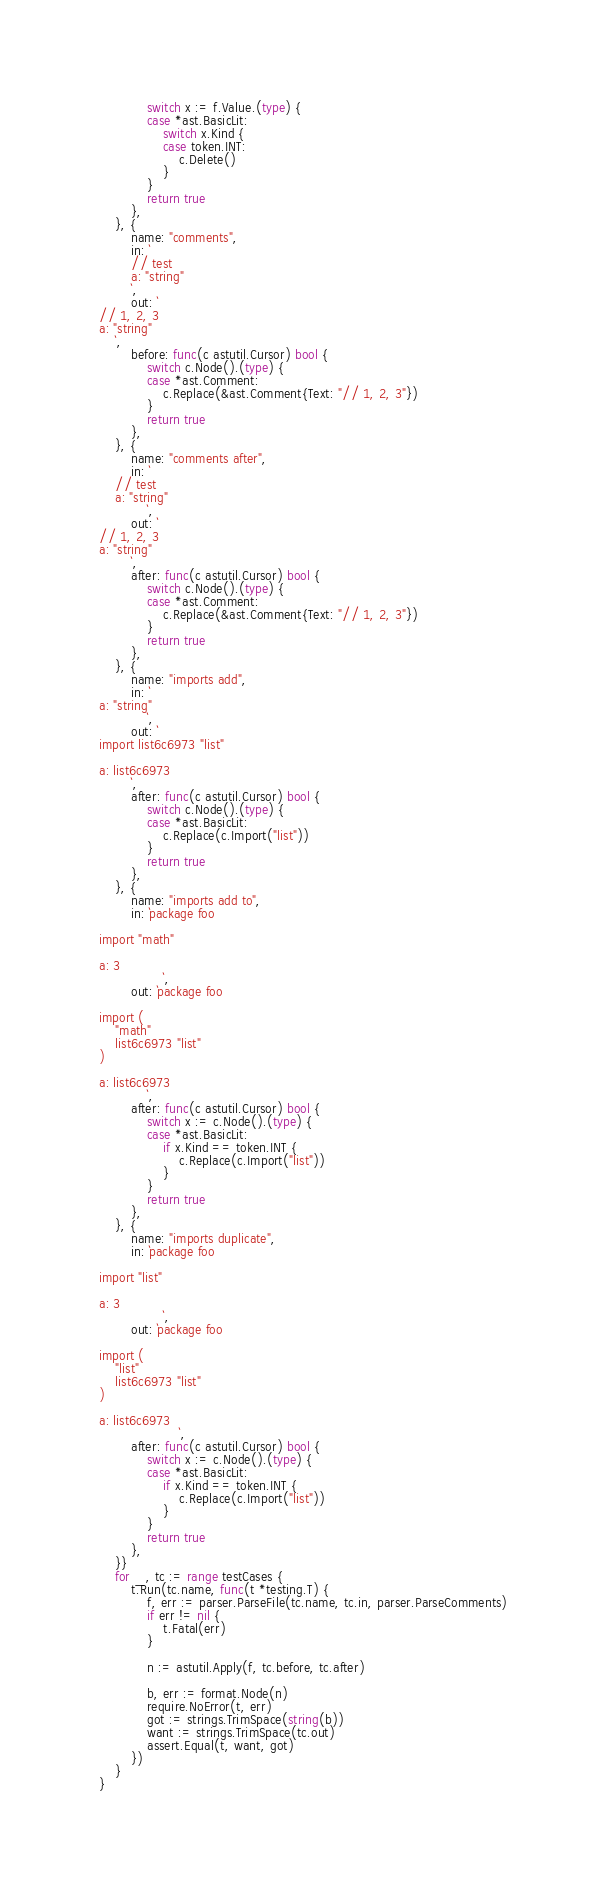Convert code to text. <code><loc_0><loc_0><loc_500><loc_500><_Go_>			switch x := f.Value.(type) {
			case *ast.BasicLit:
				switch x.Kind {
				case token.INT:
					c.Delete()
				}
			}
			return true
		},
	}, {
		name: "comments",
		in: `
		// test
		a: "string"
		`,
		out: `
// 1, 2, 3
a: "string"
	`,
		before: func(c astutil.Cursor) bool {
			switch c.Node().(type) {
			case *ast.Comment:
				c.Replace(&ast.Comment{Text: "// 1, 2, 3"})
			}
			return true
		},
	}, {
		name: "comments after",
		in: `
	// test
	a: "string"
			`,
		out: `
// 1, 2, 3
a: "string"
		`,
		after: func(c astutil.Cursor) bool {
			switch c.Node().(type) {
			case *ast.Comment:
				c.Replace(&ast.Comment{Text: "// 1, 2, 3"})
			}
			return true
		},
	}, {
		name: "imports add",
		in: `
a: "string"
			`,
		out: `
import list6c6973 "list"

a: list6c6973
		`,
		after: func(c astutil.Cursor) bool {
			switch c.Node().(type) {
			case *ast.BasicLit:
				c.Replace(c.Import("list"))
			}
			return true
		},
	}, {
		name: "imports add to",
		in: `package foo

import "math"

a: 3
				`,
		out: `package foo

import (
	"math"
	list6c6973 "list"
)

a: list6c6973
			`,
		after: func(c astutil.Cursor) bool {
			switch x := c.Node().(type) {
			case *ast.BasicLit:
				if x.Kind == token.INT {
					c.Replace(c.Import("list"))
				}
			}
			return true
		},
	}, {
		name: "imports duplicate",
		in: `package foo

import "list"

a: 3
				`,
		out: `package foo

import (
	"list"
	list6c6973 "list"
)

a: list6c6973
					`,
		after: func(c astutil.Cursor) bool {
			switch x := c.Node().(type) {
			case *ast.BasicLit:
				if x.Kind == token.INT {
					c.Replace(c.Import("list"))
				}
			}
			return true
		},
	}}
	for _, tc := range testCases {
		t.Run(tc.name, func(t *testing.T) {
			f, err := parser.ParseFile(tc.name, tc.in, parser.ParseComments)
			if err != nil {
				t.Fatal(err)
			}

			n := astutil.Apply(f, tc.before, tc.after)

			b, err := format.Node(n)
			require.NoError(t, err)
			got := strings.TrimSpace(string(b))
			want := strings.TrimSpace(tc.out)
			assert.Equal(t, want, got)
		})
	}
}
</code> 